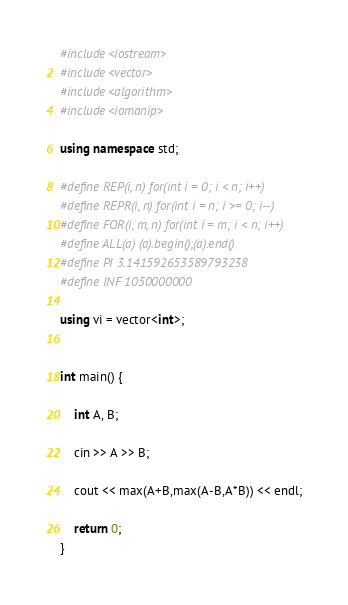Convert code to text. <code><loc_0><loc_0><loc_500><loc_500><_C++_>#include<iostream>
#include<vector>
#include<algorithm>
#include<iomanip>

using namespace std;

#define REP(i, n) for(int i = 0; i < n; i++)
#define REPR(i, n) for(int i = n; i >= 0; i--)
#define FOR(i, m, n) for(int i = m; i < n; i++)
#define ALL(a) (a).begin(),(a).end()
#define PI 3.141592653589793238
#define INF 1050000000

using vi = vector<int>;


int main() {

	int A, B;

	cin >> A >> B;

	cout << max(A+B,max(A-B,A*B)) << endl;

	return 0;
}</code> 